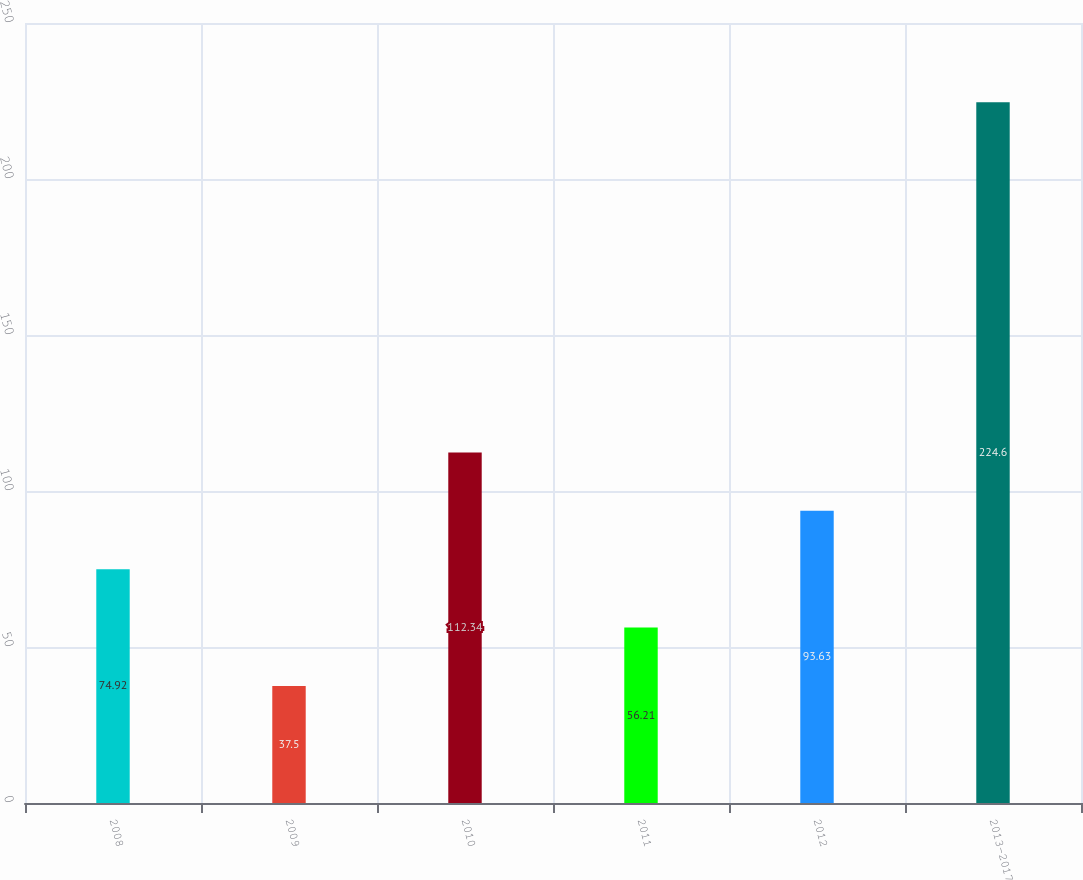<chart> <loc_0><loc_0><loc_500><loc_500><bar_chart><fcel>2008<fcel>2009<fcel>2010<fcel>2011<fcel>2012<fcel>2013-2017<nl><fcel>74.92<fcel>37.5<fcel>112.34<fcel>56.21<fcel>93.63<fcel>224.6<nl></chart> 